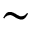Convert formula to latex. <formula><loc_0><loc_0><loc_500><loc_500>\sim</formula> 